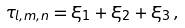<formula> <loc_0><loc_0><loc_500><loc_500>\tau _ { l , m , n } = \xi _ { 1 } + \xi _ { 2 } + \xi _ { 3 } \, ,</formula> 